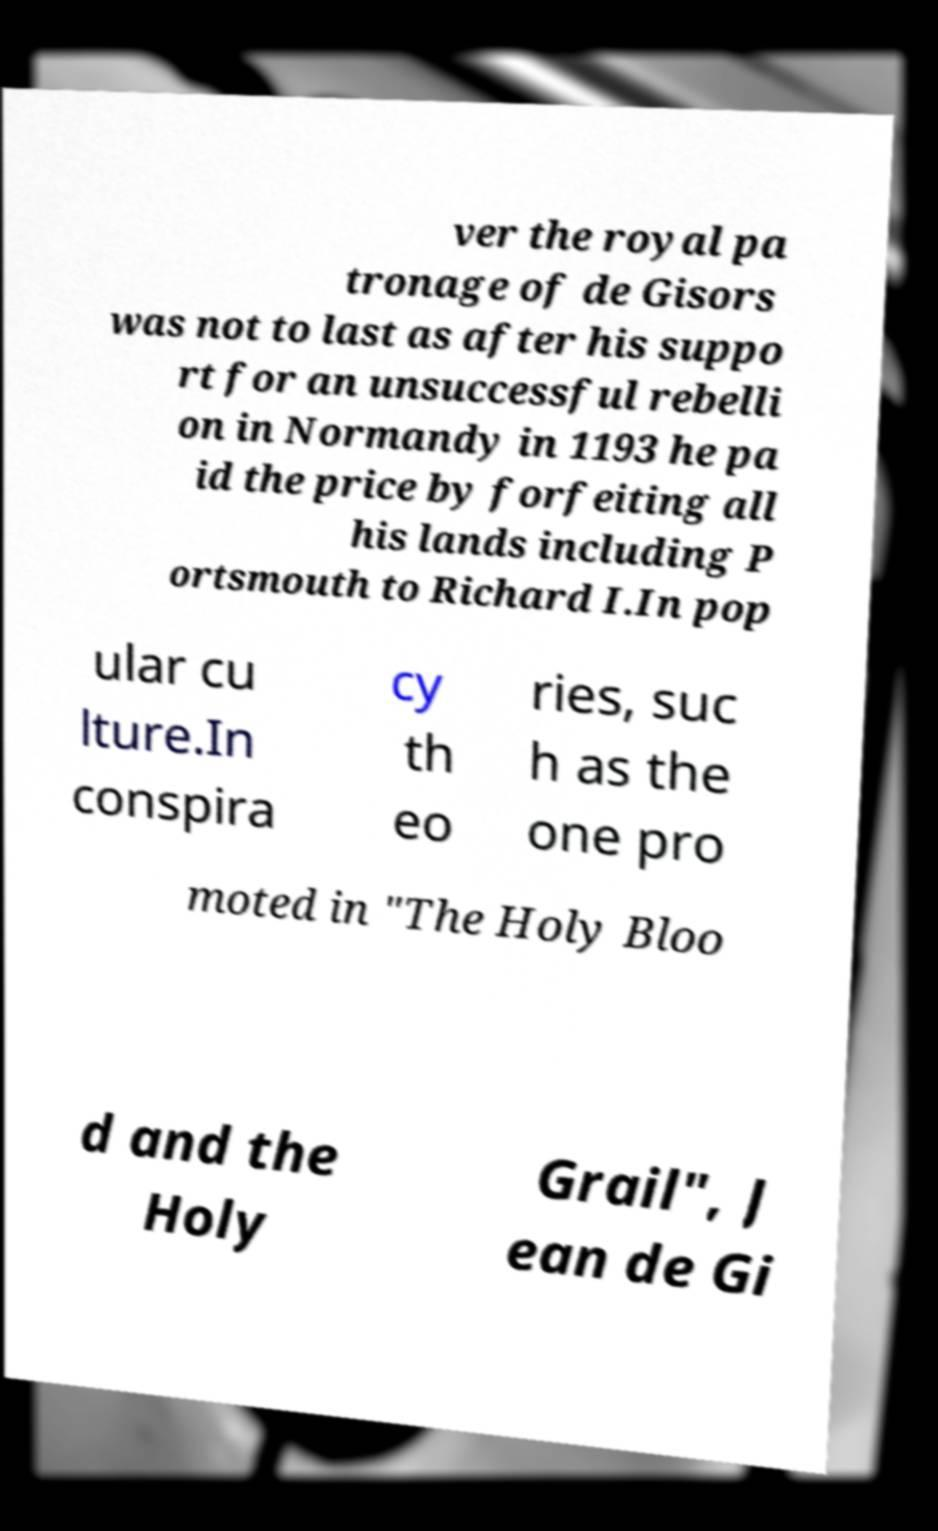Please read and relay the text visible in this image. What does it say? ver the royal pa tronage of de Gisors was not to last as after his suppo rt for an unsuccessful rebelli on in Normandy in 1193 he pa id the price by forfeiting all his lands including P ortsmouth to Richard I.In pop ular cu lture.In conspira cy th eo ries, suc h as the one pro moted in "The Holy Bloo d and the Holy Grail", J ean de Gi 